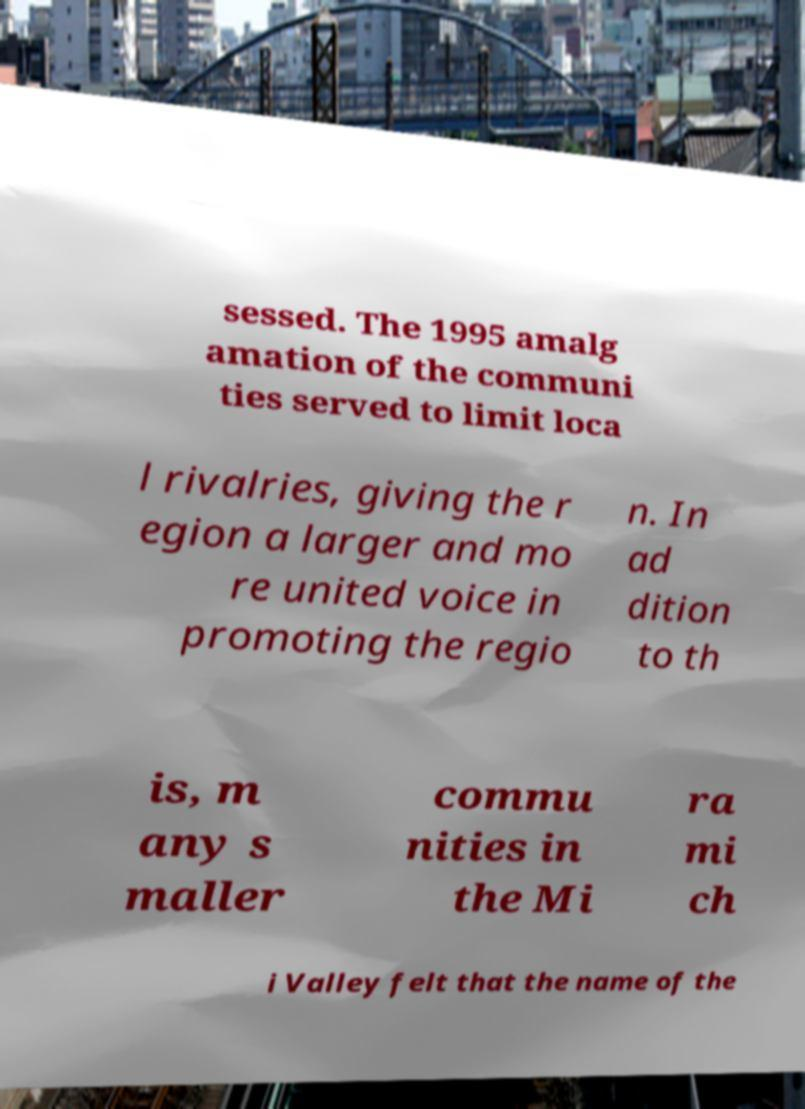Please identify and transcribe the text found in this image. sessed. The 1995 amalg amation of the communi ties served to limit loca l rivalries, giving the r egion a larger and mo re united voice in promoting the regio n. In ad dition to th is, m any s maller commu nities in the Mi ra mi ch i Valley felt that the name of the 